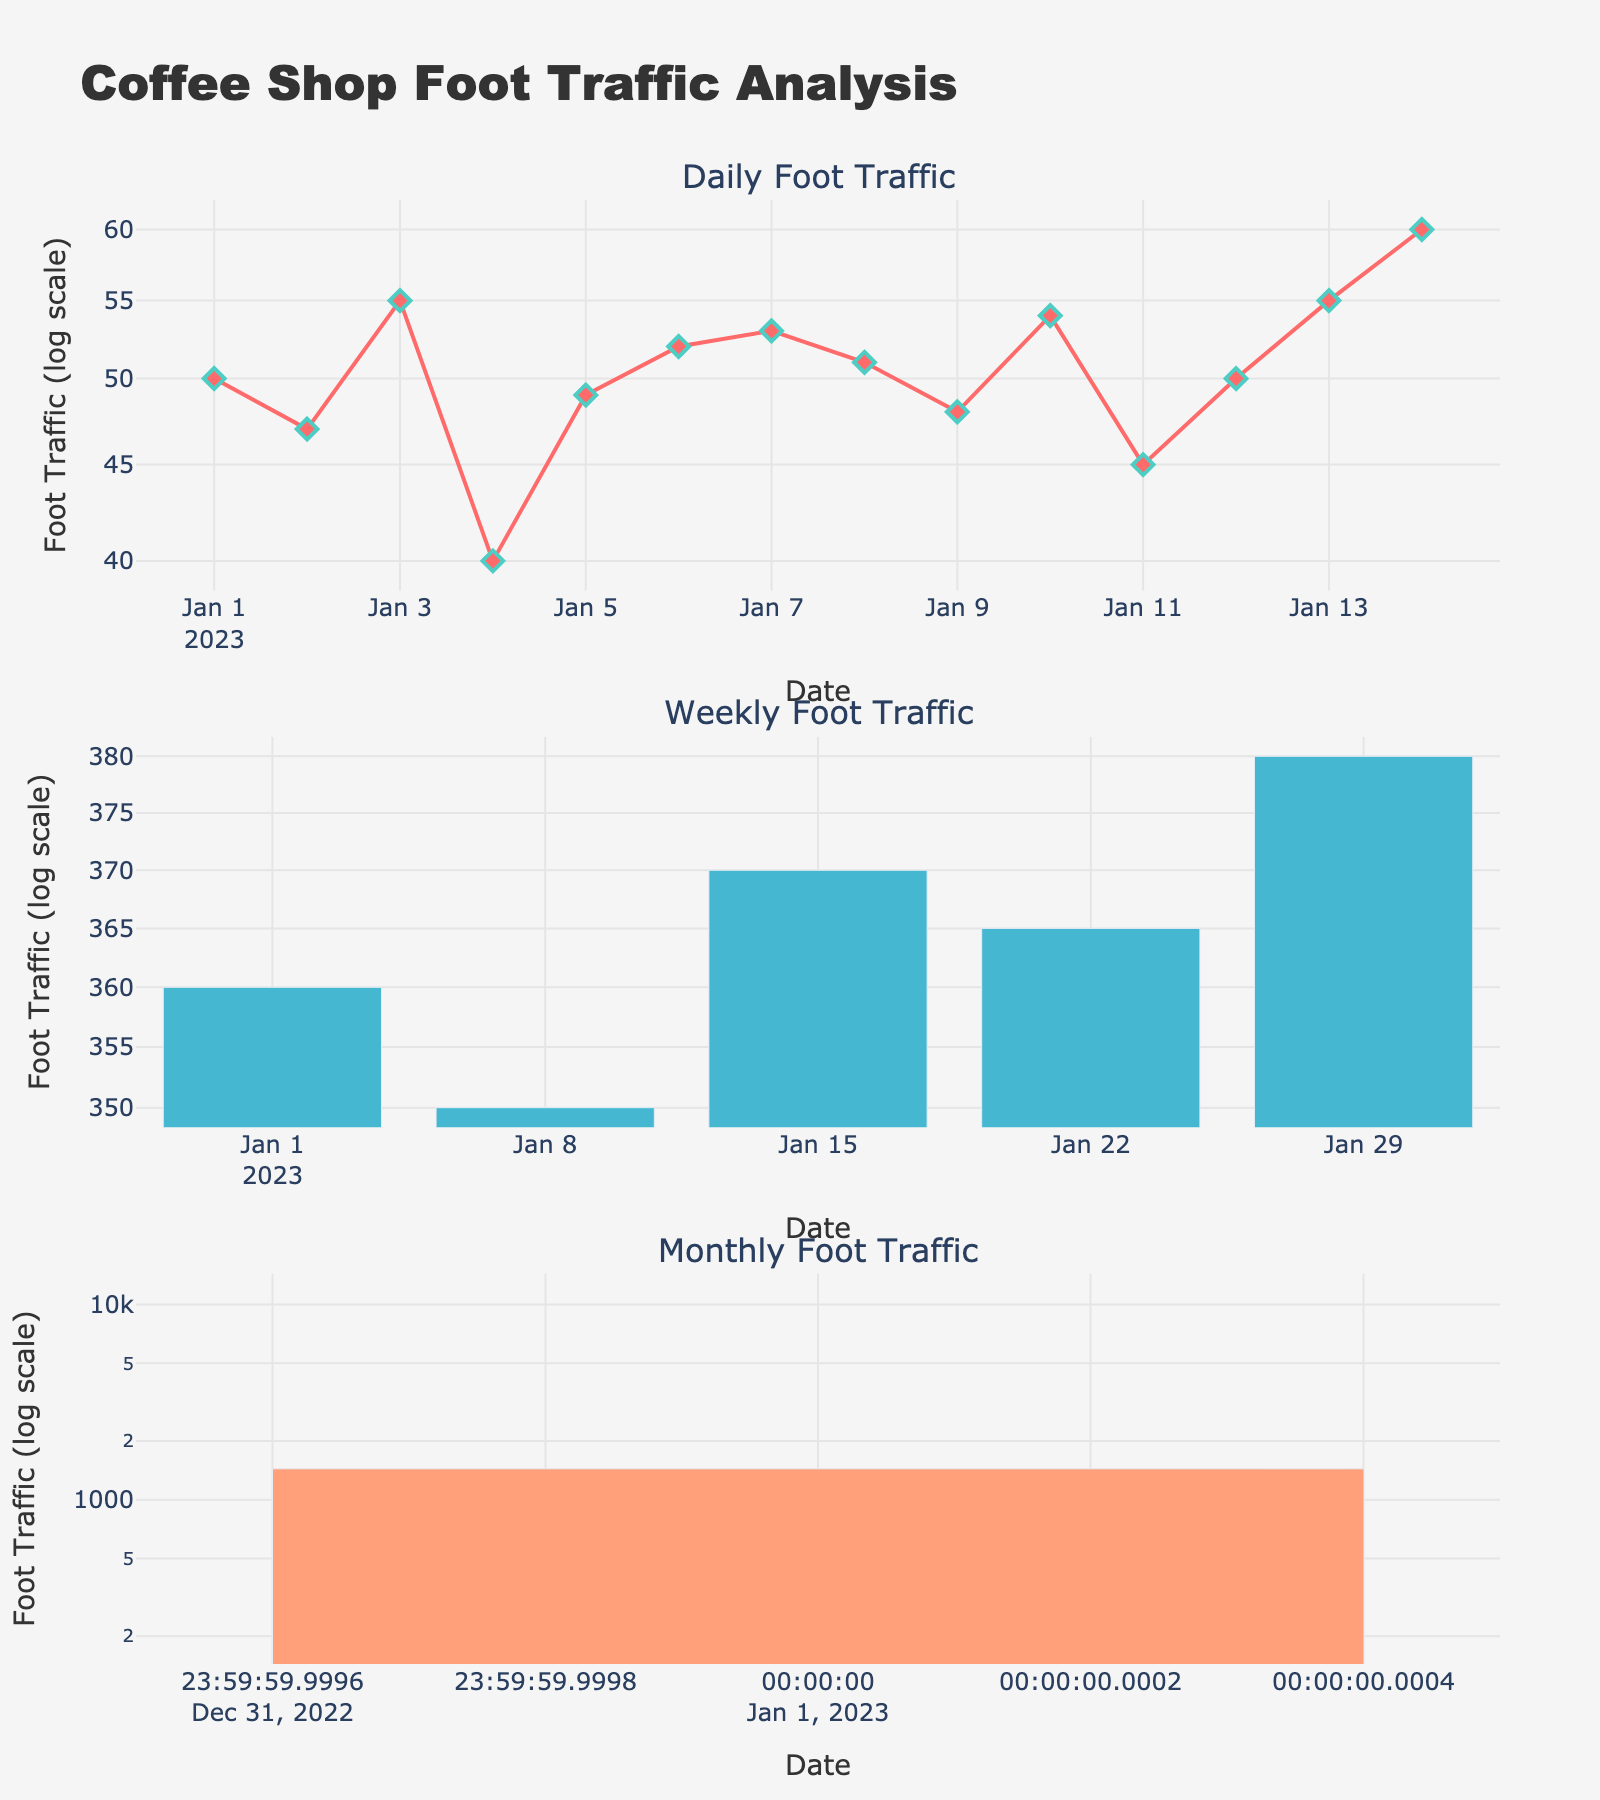What is the title of the figure? The title of the figure is usually displayed at the top center. In this case, it reads "Coffee Shop Foot Traffic Analysis."
Answer: Coffee Shop Foot Traffic Analysis How many subplot titles are present and what are they? The figure contains three subplot titles: "Daily Foot Traffic," "Weekly Foot Traffic," and "Monthly Foot Traffic." These titles are positioned above each of their respective subplots.
Answer: Three: Daily Foot Traffic, Weekly Foot Traffic, Monthly Foot Traffic What is the color of the line used in the daily foot traffic subplot? The line color in the daily foot traffic subplot is a shade of red.
Answer: Red What is the foot traffic value for the daily foot traffic on January 14, 2023? By looking at the Daily Foot Traffic subplot, the value for January 14, 2023, is found at the marker point which is highest among the daily, and its value is 60.
Answer: 60 How does the foot traffic for January 1, 2023, compare between the daily, weekly, and monthly categories? By comparing the three subplots, the foot traffic values are 50 for daily, 360 for weekly, and 1440 for monthly. The monthly value is the highest, followed by the weekly, and the daily is the lowest.
Answer: 1440 > 360 > 50 What is the trend observed in the weekly foot traffic subplot? The weekly foot traffic shows a generally increasing trend. This can be observed by the heights of the bars for each week of January 2023, which increase from 360 to 380.
Answer: Increasing Which subplot uses a logarithmic scale for the y-axis? All three subplots use a logarithmic scale for the y-axis as indicated by the 'log scale' label and the distribution of the tick marks.
Answer: All three What is the average foot traffic for weekly data points in January 2023? The weekly data points are 360, 350, 370, 365, and 380. The sum is 360 + 350 + 370 + 365 + 380 = 1825. The average is 1825 / 5 = 365.
Answer: 365 How does the daily foot traffic on January 13, 2023, compare with January 5, 2023? The daily foot traffic for January 13 and January 5 can be found in the Daily Foot Traffic subplot. For January 13, it is 55, and for January 5, it is 49. Therefore, January 13 has higher foot traffic than January 5.
Answer: 55 > 49 What is the range of foot traffic values for the daily subplot? The range is calculated by finding the difference between the highest and lowest values in the daily subplot. The highest value is 60 (January 14), and the lowest is 40 (January 4). Hence, the range is 60 - 40 = 20.
Answer: 20 